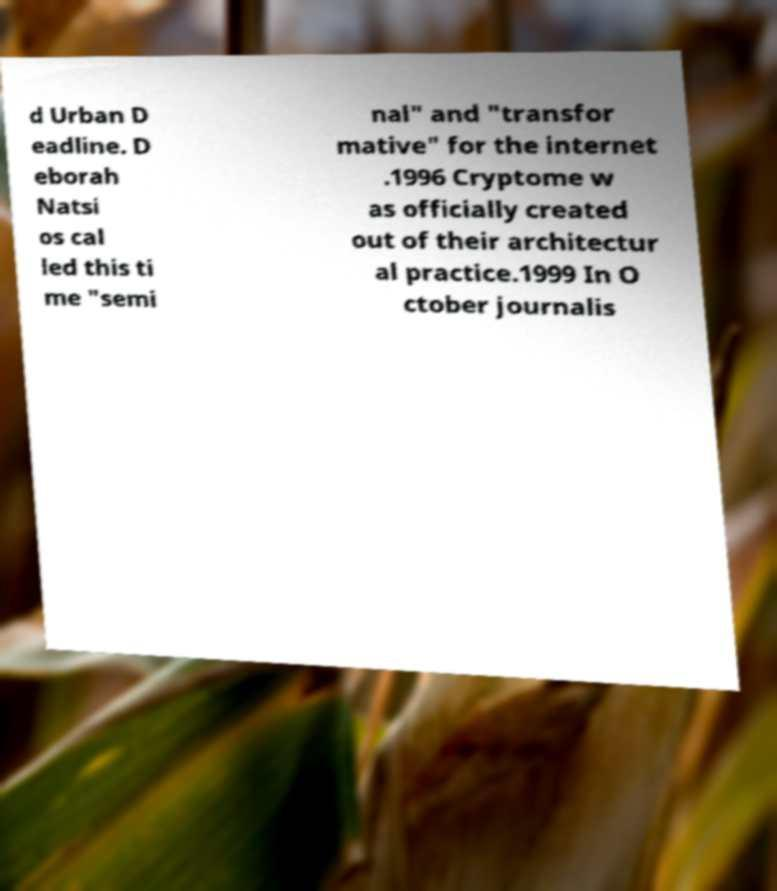Please read and relay the text visible in this image. What does it say? d Urban D eadline. D eborah Natsi os cal led this ti me "semi nal" and "transfor mative" for the internet .1996 Cryptome w as officially created out of their architectur al practice.1999 In O ctober journalis 